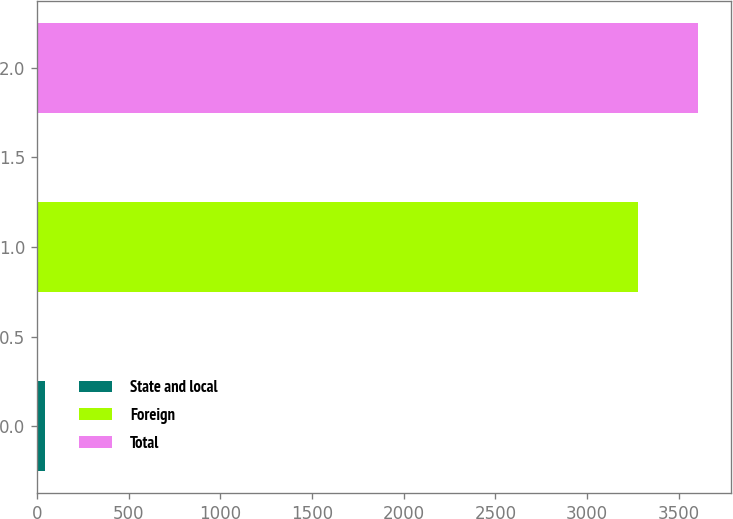<chart> <loc_0><loc_0><loc_500><loc_500><bar_chart><fcel>State and local<fcel>Foreign<fcel>Total<nl><fcel>45<fcel>3275<fcel>3604.2<nl></chart> 